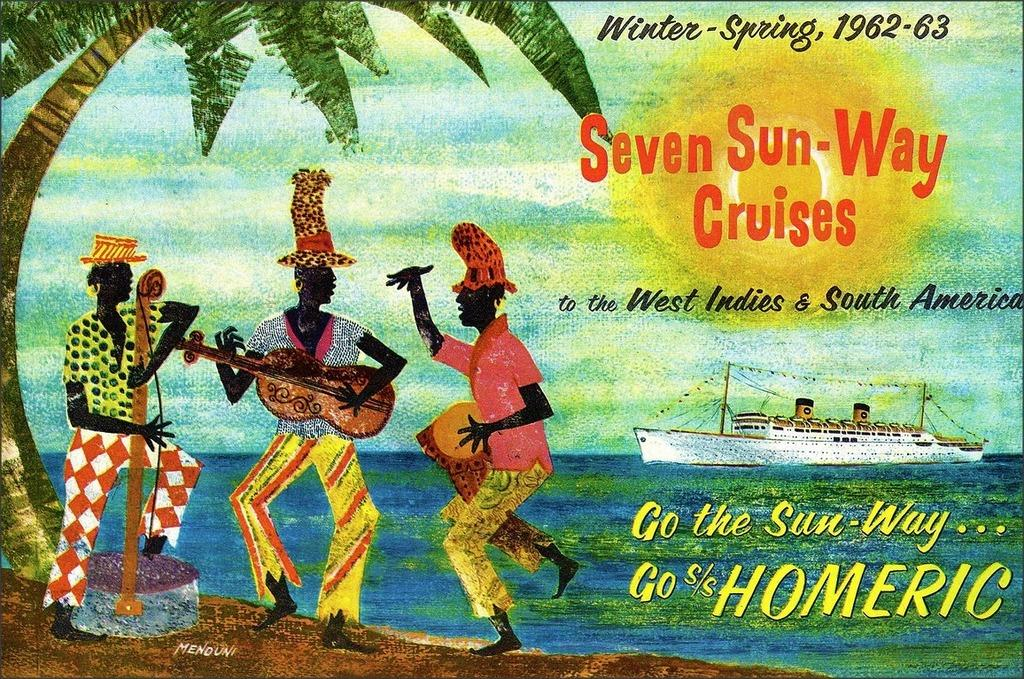<image>
Create a compact narrative representing the image presented. An ad for Seven Sun-Way Cruises is dated Winter-Spring, 1962-63. 